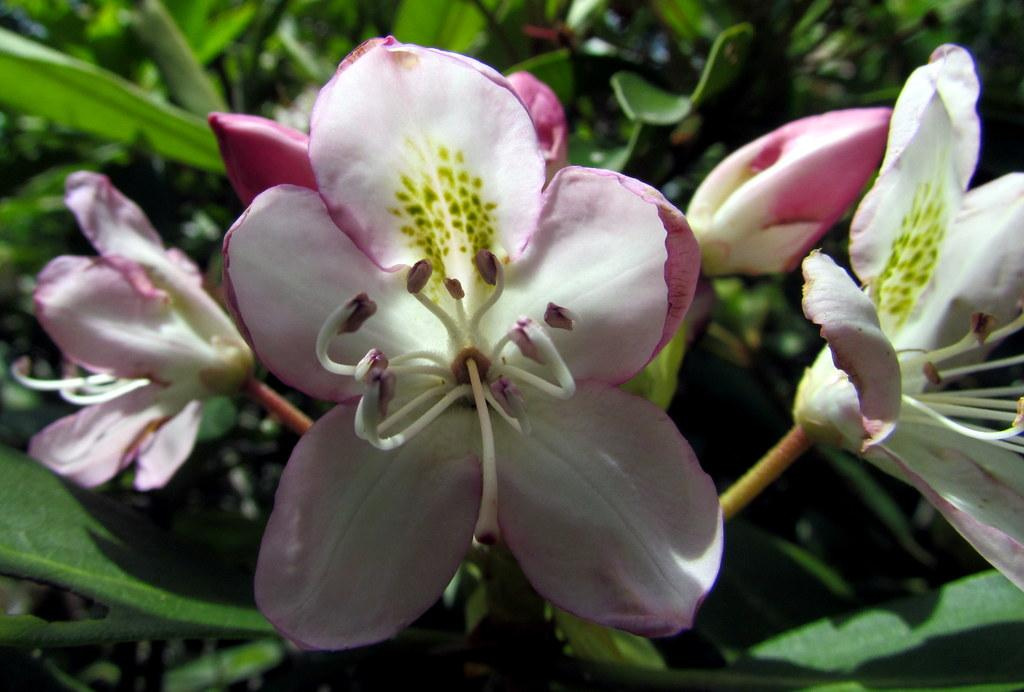What colors are the flowers in the image? The flowers in the image are pink and white. What stage of growth are the flowers in? The flowers have flower buds. What type of vegetation is visible in the background of the image? There are green plants in the background of the image. What type of experience does the flower have in the image? Flowers do not have experiences, as they are inanimate objects. 